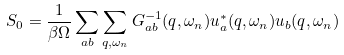Convert formula to latex. <formula><loc_0><loc_0><loc_500><loc_500>S _ { 0 } = \frac { 1 } { \beta \Omega } \sum _ { a b } \sum _ { q , \omega _ { n } } G ^ { - 1 } _ { a b } ( q , \omega _ { n } ) u _ { a } ^ { * } ( q , \omega _ { n } ) u _ { b } ( q , \omega _ { n } )</formula> 